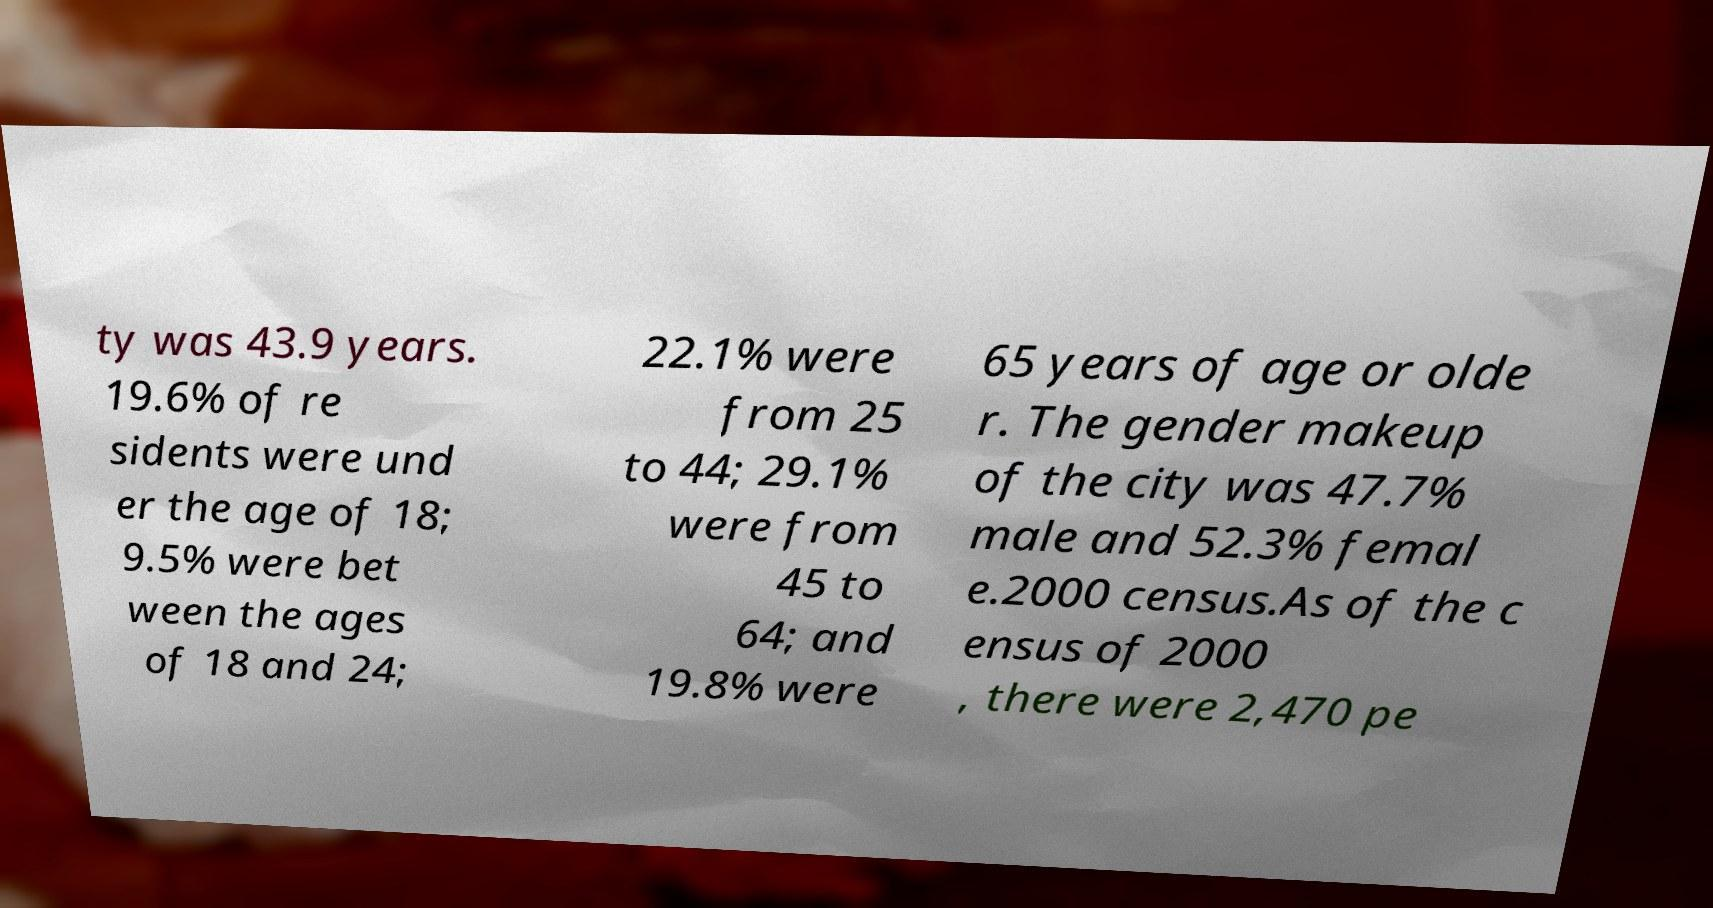Can you read and provide the text displayed in the image?This photo seems to have some interesting text. Can you extract and type it out for me? ty was 43.9 years. 19.6% of re sidents were und er the age of 18; 9.5% were bet ween the ages of 18 and 24; 22.1% were from 25 to 44; 29.1% were from 45 to 64; and 19.8% were 65 years of age or olde r. The gender makeup of the city was 47.7% male and 52.3% femal e.2000 census.As of the c ensus of 2000 , there were 2,470 pe 